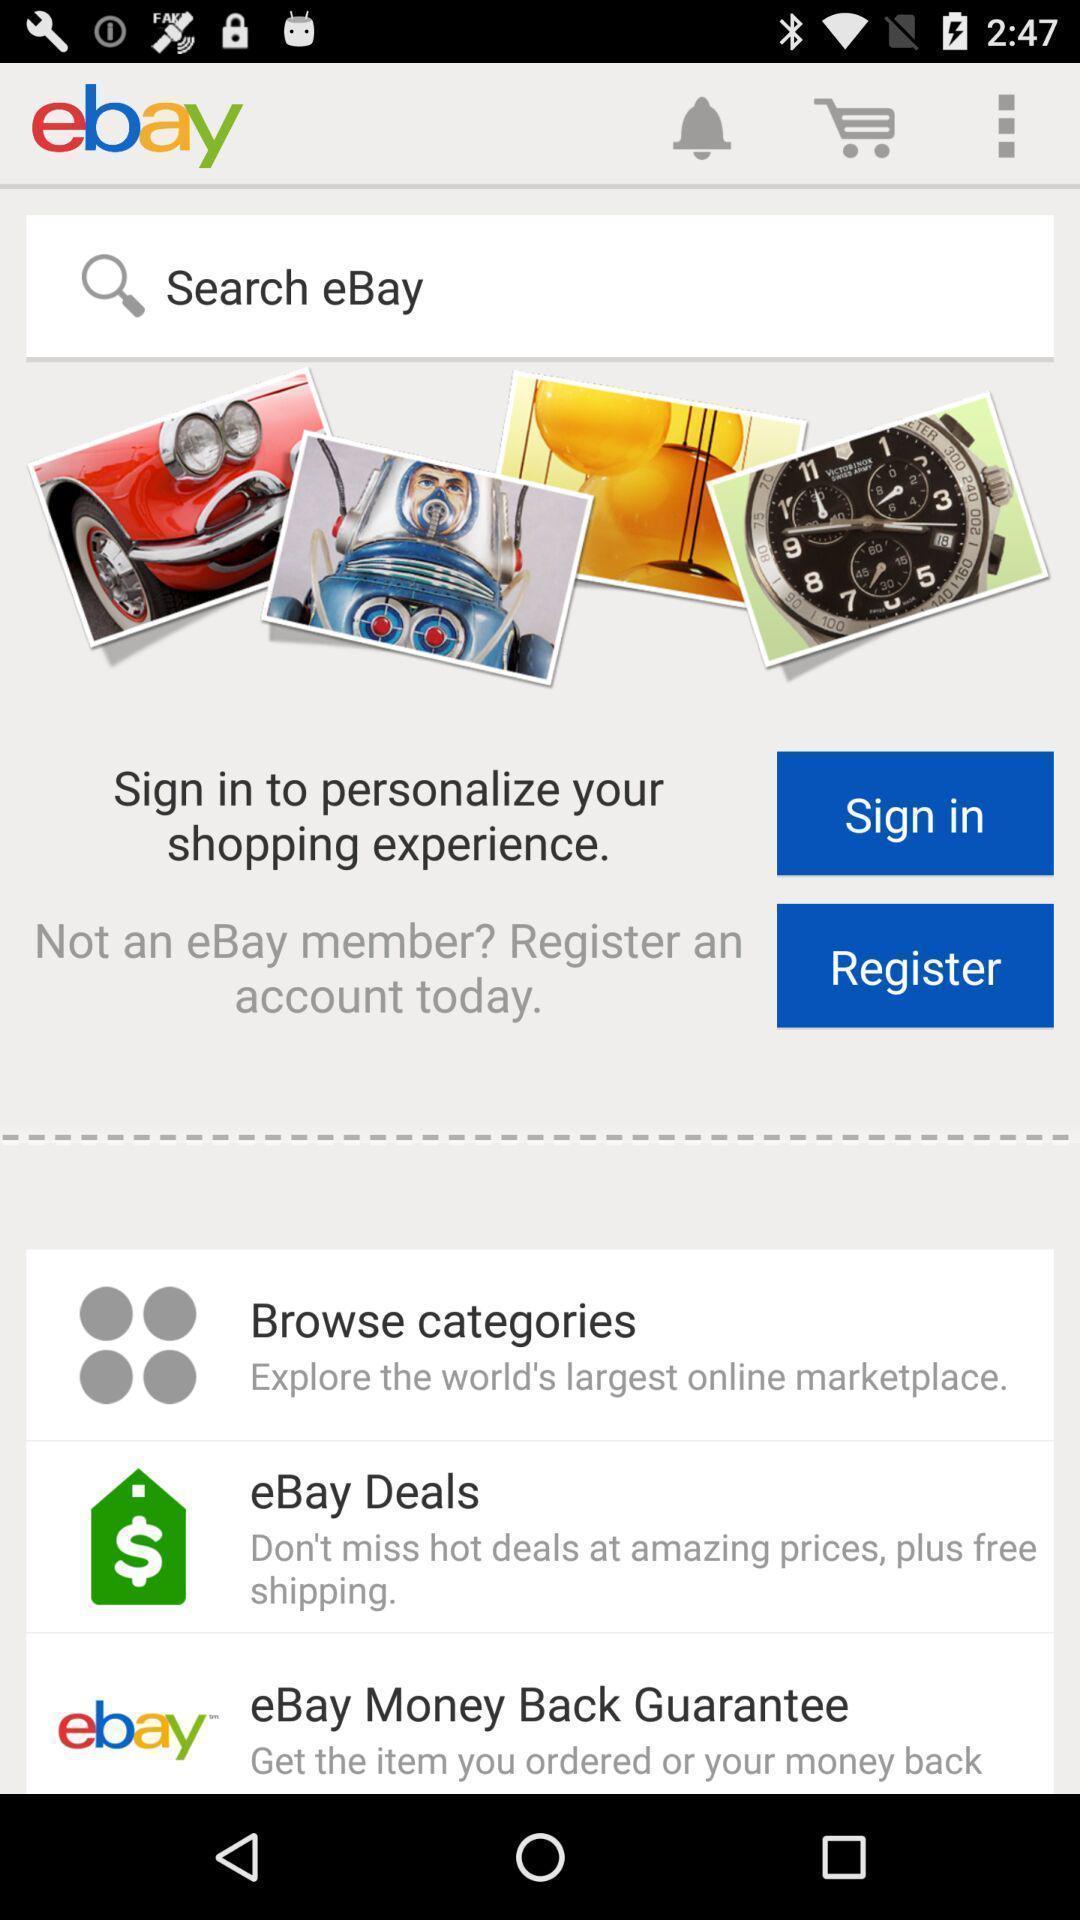Give me a narrative description of this picture. Sign in page of a shopping app. 